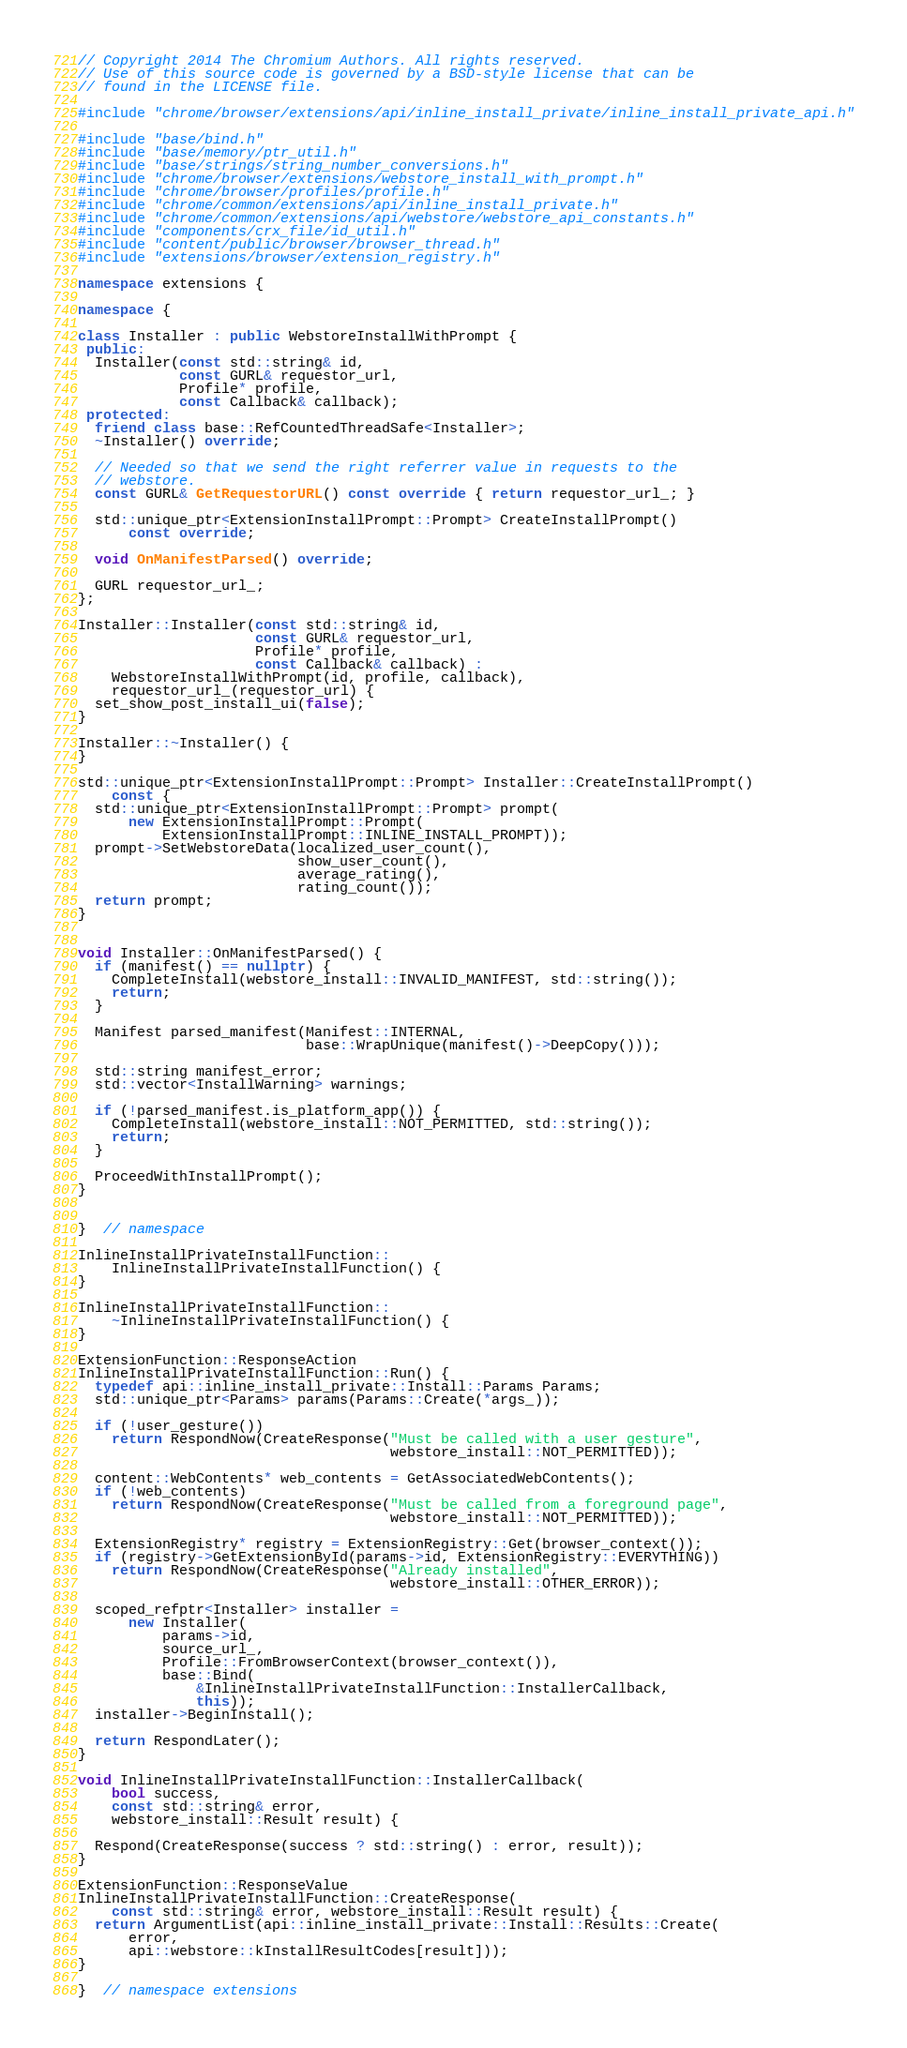Convert code to text. <code><loc_0><loc_0><loc_500><loc_500><_C++_>// Copyright 2014 The Chromium Authors. All rights reserved.
// Use of this source code is governed by a BSD-style license that can be
// found in the LICENSE file.

#include "chrome/browser/extensions/api/inline_install_private/inline_install_private_api.h"

#include "base/bind.h"
#include "base/memory/ptr_util.h"
#include "base/strings/string_number_conversions.h"
#include "chrome/browser/extensions/webstore_install_with_prompt.h"
#include "chrome/browser/profiles/profile.h"
#include "chrome/common/extensions/api/inline_install_private.h"
#include "chrome/common/extensions/api/webstore/webstore_api_constants.h"
#include "components/crx_file/id_util.h"
#include "content/public/browser/browser_thread.h"
#include "extensions/browser/extension_registry.h"

namespace extensions {

namespace {

class Installer : public WebstoreInstallWithPrompt {
 public:
  Installer(const std::string& id,
            const GURL& requestor_url,
            Profile* profile,
            const Callback& callback);
 protected:
  friend class base::RefCountedThreadSafe<Installer>;
  ~Installer() override;

  // Needed so that we send the right referrer value in requests to the
  // webstore.
  const GURL& GetRequestorURL() const override { return requestor_url_; }

  std::unique_ptr<ExtensionInstallPrompt::Prompt> CreateInstallPrompt()
      const override;

  void OnManifestParsed() override;

  GURL requestor_url_;
};

Installer::Installer(const std::string& id,
                     const GURL& requestor_url,
                     Profile* profile,
                     const Callback& callback) :
    WebstoreInstallWithPrompt(id, profile, callback),
    requestor_url_(requestor_url) {
  set_show_post_install_ui(false);
}

Installer::~Installer() {
}

std::unique_ptr<ExtensionInstallPrompt::Prompt> Installer::CreateInstallPrompt()
    const {
  std::unique_ptr<ExtensionInstallPrompt::Prompt> prompt(
      new ExtensionInstallPrompt::Prompt(
          ExtensionInstallPrompt::INLINE_INSTALL_PROMPT));
  prompt->SetWebstoreData(localized_user_count(),
                          show_user_count(),
                          average_rating(),
                          rating_count());
  return prompt;
}


void Installer::OnManifestParsed() {
  if (manifest() == nullptr) {
    CompleteInstall(webstore_install::INVALID_MANIFEST, std::string());
    return;
  }

  Manifest parsed_manifest(Manifest::INTERNAL,
                           base::WrapUnique(manifest()->DeepCopy()));

  std::string manifest_error;
  std::vector<InstallWarning> warnings;

  if (!parsed_manifest.is_platform_app()) {
    CompleteInstall(webstore_install::NOT_PERMITTED, std::string());
    return;
  }

  ProceedWithInstallPrompt();
}


}  // namespace

InlineInstallPrivateInstallFunction::
    InlineInstallPrivateInstallFunction() {
}

InlineInstallPrivateInstallFunction::
    ~InlineInstallPrivateInstallFunction() {
}

ExtensionFunction::ResponseAction
InlineInstallPrivateInstallFunction::Run() {
  typedef api::inline_install_private::Install::Params Params;
  std::unique_ptr<Params> params(Params::Create(*args_));

  if (!user_gesture())
    return RespondNow(CreateResponse("Must be called with a user gesture",
                                     webstore_install::NOT_PERMITTED));

  content::WebContents* web_contents = GetAssociatedWebContents();
  if (!web_contents)
    return RespondNow(CreateResponse("Must be called from a foreground page",
                                     webstore_install::NOT_PERMITTED));

  ExtensionRegistry* registry = ExtensionRegistry::Get(browser_context());
  if (registry->GetExtensionById(params->id, ExtensionRegistry::EVERYTHING))
    return RespondNow(CreateResponse("Already installed",
                                     webstore_install::OTHER_ERROR));

  scoped_refptr<Installer> installer =
      new Installer(
          params->id,
          source_url_,
          Profile::FromBrowserContext(browser_context()),
          base::Bind(
              &InlineInstallPrivateInstallFunction::InstallerCallback,
              this));
  installer->BeginInstall();

  return RespondLater();
}

void InlineInstallPrivateInstallFunction::InstallerCallback(
    bool success,
    const std::string& error,
    webstore_install::Result result) {

  Respond(CreateResponse(success ? std::string() : error, result));
}

ExtensionFunction::ResponseValue
InlineInstallPrivateInstallFunction::CreateResponse(
    const std::string& error, webstore_install::Result result) {
  return ArgumentList(api::inline_install_private::Install::Results::Create(
      error,
      api::webstore::kInstallResultCodes[result]));
}

}  // namespace extensions
</code> 